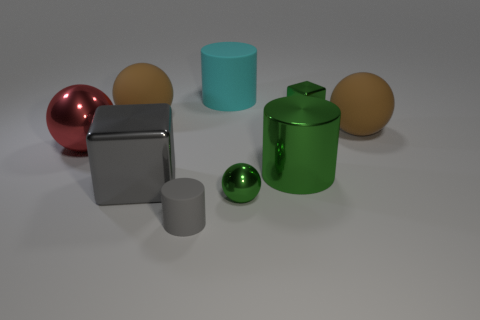There is a red thing that is the same size as the green cylinder; what shape is it?
Provide a succinct answer. Sphere. How many things are brown things or tiny red metal spheres?
Your answer should be very brief. 2. Are there any gray metal cubes?
Give a very brief answer. Yes. Is the number of matte objects less than the number of tiny shiny things?
Keep it short and to the point. No. Are there any brown things of the same size as the gray cylinder?
Give a very brief answer. No. Is the shape of the gray shiny object the same as the matte thing in front of the big red thing?
Provide a succinct answer. No. How many balls are either big red objects or large green objects?
Your response must be concise. 1. The big matte cylinder is what color?
Give a very brief answer. Cyan. Are there more gray blocks than brown matte things?
Your response must be concise. No. How many things are either shiny blocks that are behind the red metallic ball or big green objects?
Offer a very short reply. 2. 